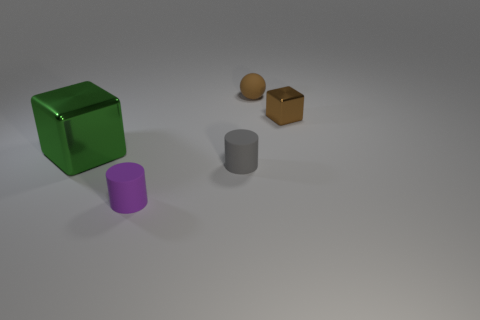Add 1 rubber cylinders. How many objects exist? 6 Subtract all cubes. How many objects are left? 3 Subtract 1 spheres. How many spheres are left? 0 Subtract all gray balls. Subtract all red cylinders. How many balls are left? 1 Subtract all cyan spheres. How many green cubes are left? 1 Subtract all large green matte cubes. Subtract all green cubes. How many objects are left? 4 Add 5 small rubber cylinders. How many small rubber cylinders are left? 7 Add 5 brown metal cubes. How many brown metal cubes exist? 6 Subtract 0 green cylinders. How many objects are left? 5 